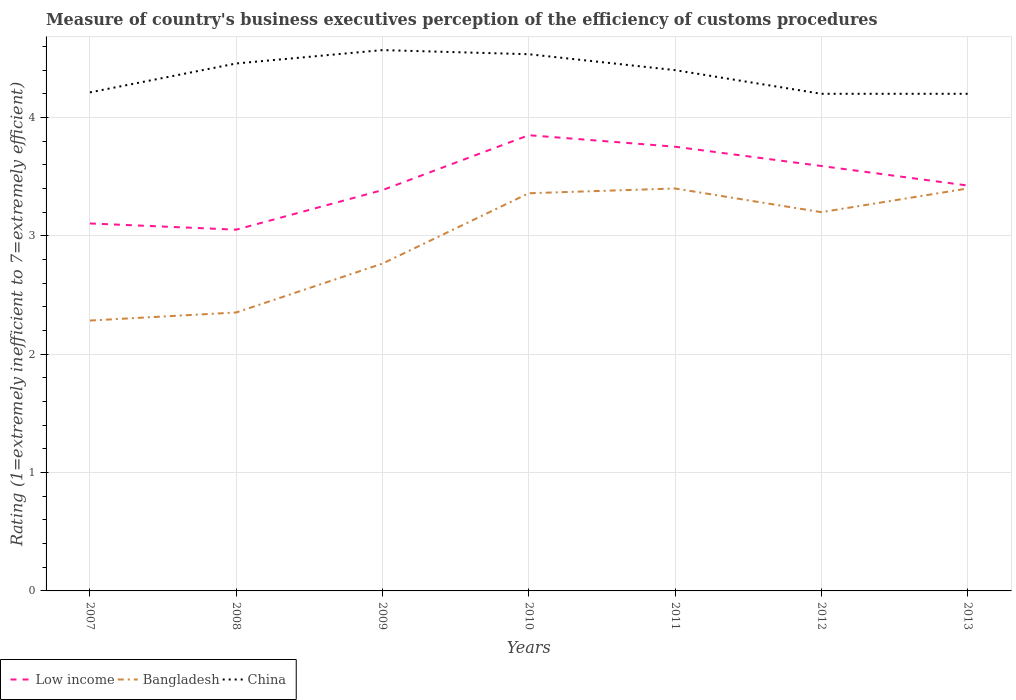How many different coloured lines are there?
Provide a succinct answer. 3. Does the line corresponding to China intersect with the line corresponding to Low income?
Offer a very short reply. No. Is the number of lines equal to the number of legend labels?
Give a very brief answer. Yes. Across all years, what is the maximum rating of the efficiency of customs procedure in Low income?
Offer a very short reply. 3.05. What is the total rating of the efficiency of customs procedure in China in the graph?
Your answer should be very brief. 0.2. What is the difference between the highest and the second highest rating of the efficiency of customs procedure in China?
Ensure brevity in your answer.  0.37. How many lines are there?
Your answer should be very brief. 3. How many years are there in the graph?
Your response must be concise. 7. What is the difference between two consecutive major ticks on the Y-axis?
Keep it short and to the point. 1. Are the values on the major ticks of Y-axis written in scientific E-notation?
Give a very brief answer. No. How many legend labels are there?
Keep it short and to the point. 3. What is the title of the graph?
Provide a succinct answer. Measure of country's business executives perception of the efficiency of customs procedures. Does "Peru" appear as one of the legend labels in the graph?
Make the answer very short. No. What is the label or title of the X-axis?
Provide a short and direct response. Years. What is the label or title of the Y-axis?
Ensure brevity in your answer.  Rating (1=extremely inefficient to 7=extremely efficient). What is the Rating (1=extremely inefficient to 7=extremely efficient) of Low income in 2007?
Provide a succinct answer. 3.1. What is the Rating (1=extremely inefficient to 7=extremely efficient) of Bangladesh in 2007?
Give a very brief answer. 2.28. What is the Rating (1=extremely inefficient to 7=extremely efficient) of China in 2007?
Offer a very short reply. 4.21. What is the Rating (1=extremely inefficient to 7=extremely efficient) in Low income in 2008?
Give a very brief answer. 3.05. What is the Rating (1=extremely inefficient to 7=extremely efficient) in Bangladesh in 2008?
Make the answer very short. 2.35. What is the Rating (1=extremely inefficient to 7=extremely efficient) of China in 2008?
Your response must be concise. 4.46. What is the Rating (1=extremely inefficient to 7=extremely efficient) of Low income in 2009?
Offer a terse response. 3.39. What is the Rating (1=extremely inefficient to 7=extremely efficient) of Bangladesh in 2009?
Provide a short and direct response. 2.77. What is the Rating (1=extremely inefficient to 7=extremely efficient) of China in 2009?
Make the answer very short. 4.57. What is the Rating (1=extremely inefficient to 7=extremely efficient) of Low income in 2010?
Your answer should be very brief. 3.85. What is the Rating (1=extremely inefficient to 7=extremely efficient) of Bangladesh in 2010?
Your answer should be very brief. 3.36. What is the Rating (1=extremely inefficient to 7=extremely efficient) in China in 2010?
Provide a short and direct response. 4.53. What is the Rating (1=extremely inefficient to 7=extremely efficient) of Low income in 2011?
Ensure brevity in your answer.  3.75. What is the Rating (1=extremely inefficient to 7=extremely efficient) in Low income in 2012?
Offer a very short reply. 3.59. What is the Rating (1=extremely inefficient to 7=extremely efficient) in Low income in 2013?
Your response must be concise. 3.42. Across all years, what is the maximum Rating (1=extremely inefficient to 7=extremely efficient) in Low income?
Your answer should be compact. 3.85. Across all years, what is the maximum Rating (1=extremely inefficient to 7=extremely efficient) in China?
Ensure brevity in your answer.  4.57. Across all years, what is the minimum Rating (1=extremely inefficient to 7=extremely efficient) of Low income?
Keep it short and to the point. 3.05. Across all years, what is the minimum Rating (1=extremely inefficient to 7=extremely efficient) in Bangladesh?
Offer a very short reply. 2.28. Across all years, what is the minimum Rating (1=extremely inefficient to 7=extremely efficient) in China?
Ensure brevity in your answer.  4.2. What is the total Rating (1=extremely inefficient to 7=extremely efficient) in Low income in the graph?
Provide a succinct answer. 24.16. What is the total Rating (1=extremely inefficient to 7=extremely efficient) in Bangladesh in the graph?
Ensure brevity in your answer.  20.76. What is the total Rating (1=extremely inefficient to 7=extremely efficient) in China in the graph?
Offer a very short reply. 30.57. What is the difference between the Rating (1=extremely inefficient to 7=extremely efficient) of Low income in 2007 and that in 2008?
Offer a very short reply. 0.05. What is the difference between the Rating (1=extremely inefficient to 7=extremely efficient) of Bangladesh in 2007 and that in 2008?
Provide a succinct answer. -0.07. What is the difference between the Rating (1=extremely inefficient to 7=extremely efficient) in China in 2007 and that in 2008?
Your response must be concise. -0.24. What is the difference between the Rating (1=extremely inefficient to 7=extremely efficient) in Low income in 2007 and that in 2009?
Your response must be concise. -0.28. What is the difference between the Rating (1=extremely inefficient to 7=extremely efficient) in Bangladesh in 2007 and that in 2009?
Provide a succinct answer. -0.48. What is the difference between the Rating (1=extremely inefficient to 7=extremely efficient) of China in 2007 and that in 2009?
Your response must be concise. -0.36. What is the difference between the Rating (1=extremely inefficient to 7=extremely efficient) in Low income in 2007 and that in 2010?
Offer a very short reply. -0.75. What is the difference between the Rating (1=extremely inefficient to 7=extremely efficient) of Bangladesh in 2007 and that in 2010?
Offer a terse response. -1.08. What is the difference between the Rating (1=extremely inefficient to 7=extremely efficient) in China in 2007 and that in 2010?
Provide a succinct answer. -0.32. What is the difference between the Rating (1=extremely inefficient to 7=extremely efficient) of Low income in 2007 and that in 2011?
Keep it short and to the point. -0.65. What is the difference between the Rating (1=extremely inefficient to 7=extremely efficient) in Bangladesh in 2007 and that in 2011?
Provide a succinct answer. -1.12. What is the difference between the Rating (1=extremely inefficient to 7=extremely efficient) in China in 2007 and that in 2011?
Make the answer very short. -0.19. What is the difference between the Rating (1=extremely inefficient to 7=extremely efficient) in Low income in 2007 and that in 2012?
Provide a succinct answer. -0.49. What is the difference between the Rating (1=extremely inefficient to 7=extremely efficient) in Bangladesh in 2007 and that in 2012?
Your answer should be compact. -0.92. What is the difference between the Rating (1=extremely inefficient to 7=extremely efficient) of China in 2007 and that in 2012?
Offer a very short reply. 0.01. What is the difference between the Rating (1=extremely inefficient to 7=extremely efficient) of Low income in 2007 and that in 2013?
Your answer should be very brief. -0.32. What is the difference between the Rating (1=extremely inefficient to 7=extremely efficient) in Bangladesh in 2007 and that in 2013?
Your answer should be compact. -1.12. What is the difference between the Rating (1=extremely inefficient to 7=extremely efficient) of China in 2007 and that in 2013?
Your answer should be compact. 0.01. What is the difference between the Rating (1=extremely inefficient to 7=extremely efficient) in Low income in 2008 and that in 2009?
Give a very brief answer. -0.33. What is the difference between the Rating (1=extremely inefficient to 7=extremely efficient) of Bangladesh in 2008 and that in 2009?
Give a very brief answer. -0.41. What is the difference between the Rating (1=extremely inefficient to 7=extremely efficient) in China in 2008 and that in 2009?
Give a very brief answer. -0.11. What is the difference between the Rating (1=extremely inefficient to 7=extremely efficient) in Low income in 2008 and that in 2010?
Make the answer very short. -0.8. What is the difference between the Rating (1=extremely inefficient to 7=extremely efficient) in Bangladesh in 2008 and that in 2010?
Make the answer very short. -1.01. What is the difference between the Rating (1=extremely inefficient to 7=extremely efficient) in China in 2008 and that in 2010?
Your answer should be compact. -0.08. What is the difference between the Rating (1=extremely inefficient to 7=extremely efficient) in Low income in 2008 and that in 2011?
Keep it short and to the point. -0.7. What is the difference between the Rating (1=extremely inefficient to 7=extremely efficient) of Bangladesh in 2008 and that in 2011?
Make the answer very short. -1.05. What is the difference between the Rating (1=extremely inefficient to 7=extremely efficient) of China in 2008 and that in 2011?
Your answer should be compact. 0.06. What is the difference between the Rating (1=extremely inefficient to 7=extremely efficient) in Low income in 2008 and that in 2012?
Give a very brief answer. -0.54. What is the difference between the Rating (1=extremely inefficient to 7=extremely efficient) in Bangladesh in 2008 and that in 2012?
Your answer should be compact. -0.85. What is the difference between the Rating (1=extremely inefficient to 7=extremely efficient) of China in 2008 and that in 2012?
Your answer should be very brief. 0.26. What is the difference between the Rating (1=extremely inefficient to 7=extremely efficient) in Low income in 2008 and that in 2013?
Your answer should be compact. -0.37. What is the difference between the Rating (1=extremely inefficient to 7=extremely efficient) in Bangladesh in 2008 and that in 2013?
Your response must be concise. -1.05. What is the difference between the Rating (1=extremely inefficient to 7=extremely efficient) in China in 2008 and that in 2013?
Offer a very short reply. 0.26. What is the difference between the Rating (1=extremely inefficient to 7=extremely efficient) in Low income in 2009 and that in 2010?
Provide a short and direct response. -0.46. What is the difference between the Rating (1=extremely inefficient to 7=extremely efficient) of Bangladesh in 2009 and that in 2010?
Your response must be concise. -0.59. What is the difference between the Rating (1=extremely inefficient to 7=extremely efficient) of China in 2009 and that in 2010?
Your response must be concise. 0.03. What is the difference between the Rating (1=extremely inefficient to 7=extremely efficient) of Low income in 2009 and that in 2011?
Provide a succinct answer. -0.37. What is the difference between the Rating (1=extremely inefficient to 7=extremely efficient) in Bangladesh in 2009 and that in 2011?
Provide a succinct answer. -0.63. What is the difference between the Rating (1=extremely inefficient to 7=extremely efficient) in China in 2009 and that in 2011?
Your response must be concise. 0.17. What is the difference between the Rating (1=extremely inefficient to 7=extremely efficient) in Low income in 2009 and that in 2012?
Offer a terse response. -0.2. What is the difference between the Rating (1=extremely inefficient to 7=extremely efficient) in Bangladesh in 2009 and that in 2012?
Offer a terse response. -0.43. What is the difference between the Rating (1=extremely inefficient to 7=extremely efficient) in China in 2009 and that in 2012?
Your response must be concise. 0.37. What is the difference between the Rating (1=extremely inefficient to 7=extremely efficient) in Low income in 2009 and that in 2013?
Keep it short and to the point. -0.04. What is the difference between the Rating (1=extremely inefficient to 7=extremely efficient) in Bangladesh in 2009 and that in 2013?
Give a very brief answer. -0.63. What is the difference between the Rating (1=extremely inefficient to 7=extremely efficient) of China in 2009 and that in 2013?
Give a very brief answer. 0.37. What is the difference between the Rating (1=extremely inefficient to 7=extremely efficient) in Low income in 2010 and that in 2011?
Your response must be concise. 0.1. What is the difference between the Rating (1=extremely inefficient to 7=extremely efficient) in Bangladesh in 2010 and that in 2011?
Give a very brief answer. -0.04. What is the difference between the Rating (1=extremely inefficient to 7=extremely efficient) in China in 2010 and that in 2011?
Your answer should be compact. 0.13. What is the difference between the Rating (1=extremely inefficient to 7=extremely efficient) of Low income in 2010 and that in 2012?
Offer a very short reply. 0.26. What is the difference between the Rating (1=extremely inefficient to 7=extremely efficient) of Bangladesh in 2010 and that in 2012?
Your response must be concise. 0.16. What is the difference between the Rating (1=extremely inefficient to 7=extremely efficient) of China in 2010 and that in 2012?
Your answer should be compact. 0.33. What is the difference between the Rating (1=extremely inefficient to 7=extremely efficient) in Low income in 2010 and that in 2013?
Provide a succinct answer. 0.43. What is the difference between the Rating (1=extremely inefficient to 7=extremely efficient) in Bangladesh in 2010 and that in 2013?
Give a very brief answer. -0.04. What is the difference between the Rating (1=extremely inefficient to 7=extremely efficient) of China in 2010 and that in 2013?
Ensure brevity in your answer.  0.33. What is the difference between the Rating (1=extremely inefficient to 7=extremely efficient) in Low income in 2011 and that in 2012?
Give a very brief answer. 0.16. What is the difference between the Rating (1=extremely inefficient to 7=extremely efficient) in Low income in 2011 and that in 2013?
Ensure brevity in your answer.  0.33. What is the difference between the Rating (1=extremely inefficient to 7=extremely efficient) in Bangladesh in 2011 and that in 2013?
Offer a very short reply. 0. What is the difference between the Rating (1=extremely inefficient to 7=extremely efficient) of China in 2011 and that in 2013?
Offer a terse response. 0.2. What is the difference between the Rating (1=extremely inefficient to 7=extremely efficient) of Low income in 2012 and that in 2013?
Offer a very short reply. 0.17. What is the difference between the Rating (1=extremely inefficient to 7=extremely efficient) in China in 2012 and that in 2013?
Ensure brevity in your answer.  0. What is the difference between the Rating (1=extremely inefficient to 7=extremely efficient) of Low income in 2007 and the Rating (1=extremely inefficient to 7=extremely efficient) of Bangladesh in 2008?
Offer a terse response. 0.75. What is the difference between the Rating (1=extremely inefficient to 7=extremely efficient) in Low income in 2007 and the Rating (1=extremely inefficient to 7=extremely efficient) in China in 2008?
Make the answer very short. -1.35. What is the difference between the Rating (1=extremely inefficient to 7=extremely efficient) of Bangladesh in 2007 and the Rating (1=extremely inefficient to 7=extremely efficient) of China in 2008?
Offer a terse response. -2.17. What is the difference between the Rating (1=extremely inefficient to 7=extremely efficient) of Low income in 2007 and the Rating (1=extremely inefficient to 7=extremely efficient) of Bangladesh in 2009?
Your answer should be very brief. 0.34. What is the difference between the Rating (1=extremely inefficient to 7=extremely efficient) in Low income in 2007 and the Rating (1=extremely inefficient to 7=extremely efficient) in China in 2009?
Give a very brief answer. -1.46. What is the difference between the Rating (1=extremely inefficient to 7=extremely efficient) in Bangladesh in 2007 and the Rating (1=extremely inefficient to 7=extremely efficient) in China in 2009?
Provide a succinct answer. -2.29. What is the difference between the Rating (1=extremely inefficient to 7=extremely efficient) in Low income in 2007 and the Rating (1=extremely inefficient to 7=extremely efficient) in Bangladesh in 2010?
Keep it short and to the point. -0.26. What is the difference between the Rating (1=extremely inefficient to 7=extremely efficient) in Low income in 2007 and the Rating (1=extremely inefficient to 7=extremely efficient) in China in 2010?
Keep it short and to the point. -1.43. What is the difference between the Rating (1=extremely inefficient to 7=extremely efficient) of Bangladesh in 2007 and the Rating (1=extremely inefficient to 7=extremely efficient) of China in 2010?
Ensure brevity in your answer.  -2.25. What is the difference between the Rating (1=extremely inefficient to 7=extremely efficient) in Low income in 2007 and the Rating (1=extremely inefficient to 7=extremely efficient) in Bangladesh in 2011?
Keep it short and to the point. -0.3. What is the difference between the Rating (1=extremely inefficient to 7=extremely efficient) in Low income in 2007 and the Rating (1=extremely inefficient to 7=extremely efficient) in China in 2011?
Ensure brevity in your answer.  -1.3. What is the difference between the Rating (1=extremely inefficient to 7=extremely efficient) in Bangladesh in 2007 and the Rating (1=extremely inefficient to 7=extremely efficient) in China in 2011?
Offer a terse response. -2.12. What is the difference between the Rating (1=extremely inefficient to 7=extremely efficient) of Low income in 2007 and the Rating (1=extremely inefficient to 7=extremely efficient) of Bangladesh in 2012?
Make the answer very short. -0.1. What is the difference between the Rating (1=extremely inefficient to 7=extremely efficient) in Low income in 2007 and the Rating (1=extremely inefficient to 7=extremely efficient) in China in 2012?
Give a very brief answer. -1.1. What is the difference between the Rating (1=extremely inefficient to 7=extremely efficient) in Bangladesh in 2007 and the Rating (1=extremely inefficient to 7=extremely efficient) in China in 2012?
Make the answer very short. -1.92. What is the difference between the Rating (1=extremely inefficient to 7=extremely efficient) in Low income in 2007 and the Rating (1=extremely inefficient to 7=extremely efficient) in Bangladesh in 2013?
Provide a short and direct response. -0.3. What is the difference between the Rating (1=extremely inefficient to 7=extremely efficient) in Low income in 2007 and the Rating (1=extremely inefficient to 7=extremely efficient) in China in 2013?
Provide a short and direct response. -1.1. What is the difference between the Rating (1=extremely inefficient to 7=extremely efficient) of Bangladesh in 2007 and the Rating (1=extremely inefficient to 7=extremely efficient) of China in 2013?
Your answer should be compact. -1.92. What is the difference between the Rating (1=extremely inefficient to 7=extremely efficient) in Low income in 2008 and the Rating (1=extremely inefficient to 7=extremely efficient) in Bangladesh in 2009?
Provide a short and direct response. 0.29. What is the difference between the Rating (1=extremely inefficient to 7=extremely efficient) in Low income in 2008 and the Rating (1=extremely inefficient to 7=extremely efficient) in China in 2009?
Ensure brevity in your answer.  -1.52. What is the difference between the Rating (1=extremely inefficient to 7=extremely efficient) in Bangladesh in 2008 and the Rating (1=extremely inefficient to 7=extremely efficient) in China in 2009?
Your answer should be very brief. -2.22. What is the difference between the Rating (1=extremely inefficient to 7=extremely efficient) of Low income in 2008 and the Rating (1=extremely inefficient to 7=extremely efficient) of Bangladesh in 2010?
Offer a terse response. -0.31. What is the difference between the Rating (1=extremely inefficient to 7=extremely efficient) of Low income in 2008 and the Rating (1=extremely inefficient to 7=extremely efficient) of China in 2010?
Ensure brevity in your answer.  -1.48. What is the difference between the Rating (1=extremely inefficient to 7=extremely efficient) in Bangladesh in 2008 and the Rating (1=extremely inefficient to 7=extremely efficient) in China in 2010?
Offer a terse response. -2.18. What is the difference between the Rating (1=extremely inefficient to 7=extremely efficient) in Low income in 2008 and the Rating (1=extremely inefficient to 7=extremely efficient) in Bangladesh in 2011?
Make the answer very short. -0.35. What is the difference between the Rating (1=extremely inefficient to 7=extremely efficient) in Low income in 2008 and the Rating (1=extremely inefficient to 7=extremely efficient) in China in 2011?
Keep it short and to the point. -1.35. What is the difference between the Rating (1=extremely inefficient to 7=extremely efficient) of Bangladesh in 2008 and the Rating (1=extremely inefficient to 7=extremely efficient) of China in 2011?
Provide a short and direct response. -2.05. What is the difference between the Rating (1=extremely inefficient to 7=extremely efficient) in Low income in 2008 and the Rating (1=extremely inefficient to 7=extremely efficient) in Bangladesh in 2012?
Provide a short and direct response. -0.15. What is the difference between the Rating (1=extremely inefficient to 7=extremely efficient) in Low income in 2008 and the Rating (1=extremely inefficient to 7=extremely efficient) in China in 2012?
Your answer should be very brief. -1.15. What is the difference between the Rating (1=extremely inefficient to 7=extremely efficient) in Bangladesh in 2008 and the Rating (1=extremely inefficient to 7=extremely efficient) in China in 2012?
Offer a very short reply. -1.85. What is the difference between the Rating (1=extremely inefficient to 7=extremely efficient) of Low income in 2008 and the Rating (1=extremely inefficient to 7=extremely efficient) of Bangladesh in 2013?
Offer a very short reply. -0.35. What is the difference between the Rating (1=extremely inefficient to 7=extremely efficient) in Low income in 2008 and the Rating (1=extremely inefficient to 7=extremely efficient) in China in 2013?
Offer a terse response. -1.15. What is the difference between the Rating (1=extremely inefficient to 7=extremely efficient) in Bangladesh in 2008 and the Rating (1=extremely inefficient to 7=extremely efficient) in China in 2013?
Keep it short and to the point. -1.85. What is the difference between the Rating (1=extremely inefficient to 7=extremely efficient) of Low income in 2009 and the Rating (1=extremely inefficient to 7=extremely efficient) of Bangladesh in 2010?
Offer a terse response. 0.03. What is the difference between the Rating (1=extremely inefficient to 7=extremely efficient) of Low income in 2009 and the Rating (1=extremely inefficient to 7=extremely efficient) of China in 2010?
Offer a terse response. -1.15. What is the difference between the Rating (1=extremely inefficient to 7=extremely efficient) of Bangladesh in 2009 and the Rating (1=extremely inefficient to 7=extremely efficient) of China in 2010?
Ensure brevity in your answer.  -1.77. What is the difference between the Rating (1=extremely inefficient to 7=extremely efficient) in Low income in 2009 and the Rating (1=extremely inefficient to 7=extremely efficient) in Bangladesh in 2011?
Make the answer very short. -0.01. What is the difference between the Rating (1=extremely inefficient to 7=extremely efficient) of Low income in 2009 and the Rating (1=extremely inefficient to 7=extremely efficient) of China in 2011?
Your answer should be very brief. -1.01. What is the difference between the Rating (1=extremely inefficient to 7=extremely efficient) in Bangladesh in 2009 and the Rating (1=extremely inefficient to 7=extremely efficient) in China in 2011?
Offer a very short reply. -1.63. What is the difference between the Rating (1=extremely inefficient to 7=extremely efficient) of Low income in 2009 and the Rating (1=extremely inefficient to 7=extremely efficient) of Bangladesh in 2012?
Keep it short and to the point. 0.19. What is the difference between the Rating (1=extremely inefficient to 7=extremely efficient) of Low income in 2009 and the Rating (1=extremely inefficient to 7=extremely efficient) of China in 2012?
Your answer should be very brief. -0.81. What is the difference between the Rating (1=extremely inefficient to 7=extremely efficient) in Bangladesh in 2009 and the Rating (1=extremely inefficient to 7=extremely efficient) in China in 2012?
Give a very brief answer. -1.43. What is the difference between the Rating (1=extremely inefficient to 7=extremely efficient) of Low income in 2009 and the Rating (1=extremely inefficient to 7=extremely efficient) of Bangladesh in 2013?
Keep it short and to the point. -0.01. What is the difference between the Rating (1=extremely inefficient to 7=extremely efficient) of Low income in 2009 and the Rating (1=extremely inefficient to 7=extremely efficient) of China in 2013?
Give a very brief answer. -0.81. What is the difference between the Rating (1=extremely inefficient to 7=extremely efficient) in Bangladesh in 2009 and the Rating (1=extremely inefficient to 7=extremely efficient) in China in 2013?
Offer a very short reply. -1.43. What is the difference between the Rating (1=extremely inefficient to 7=extremely efficient) in Low income in 2010 and the Rating (1=extremely inefficient to 7=extremely efficient) in Bangladesh in 2011?
Your response must be concise. 0.45. What is the difference between the Rating (1=extremely inefficient to 7=extremely efficient) in Low income in 2010 and the Rating (1=extremely inefficient to 7=extremely efficient) in China in 2011?
Your answer should be compact. -0.55. What is the difference between the Rating (1=extremely inefficient to 7=extremely efficient) in Bangladesh in 2010 and the Rating (1=extremely inefficient to 7=extremely efficient) in China in 2011?
Your answer should be compact. -1.04. What is the difference between the Rating (1=extremely inefficient to 7=extremely efficient) in Low income in 2010 and the Rating (1=extremely inefficient to 7=extremely efficient) in Bangladesh in 2012?
Offer a very short reply. 0.65. What is the difference between the Rating (1=extremely inefficient to 7=extremely efficient) of Low income in 2010 and the Rating (1=extremely inefficient to 7=extremely efficient) of China in 2012?
Give a very brief answer. -0.35. What is the difference between the Rating (1=extremely inefficient to 7=extremely efficient) in Bangladesh in 2010 and the Rating (1=extremely inefficient to 7=extremely efficient) in China in 2012?
Give a very brief answer. -0.84. What is the difference between the Rating (1=extremely inefficient to 7=extremely efficient) of Low income in 2010 and the Rating (1=extremely inefficient to 7=extremely efficient) of Bangladesh in 2013?
Ensure brevity in your answer.  0.45. What is the difference between the Rating (1=extremely inefficient to 7=extremely efficient) in Low income in 2010 and the Rating (1=extremely inefficient to 7=extremely efficient) in China in 2013?
Ensure brevity in your answer.  -0.35. What is the difference between the Rating (1=extremely inefficient to 7=extremely efficient) in Bangladesh in 2010 and the Rating (1=extremely inefficient to 7=extremely efficient) in China in 2013?
Offer a very short reply. -0.84. What is the difference between the Rating (1=extremely inefficient to 7=extremely efficient) in Low income in 2011 and the Rating (1=extremely inefficient to 7=extremely efficient) in Bangladesh in 2012?
Your answer should be very brief. 0.55. What is the difference between the Rating (1=extremely inefficient to 7=extremely efficient) in Low income in 2011 and the Rating (1=extremely inefficient to 7=extremely efficient) in China in 2012?
Keep it short and to the point. -0.45. What is the difference between the Rating (1=extremely inefficient to 7=extremely efficient) in Low income in 2011 and the Rating (1=extremely inefficient to 7=extremely efficient) in Bangladesh in 2013?
Provide a short and direct response. 0.35. What is the difference between the Rating (1=extremely inefficient to 7=extremely efficient) of Low income in 2011 and the Rating (1=extremely inefficient to 7=extremely efficient) of China in 2013?
Your answer should be very brief. -0.45. What is the difference between the Rating (1=extremely inefficient to 7=extremely efficient) of Low income in 2012 and the Rating (1=extremely inefficient to 7=extremely efficient) of Bangladesh in 2013?
Give a very brief answer. 0.19. What is the difference between the Rating (1=extremely inefficient to 7=extremely efficient) of Low income in 2012 and the Rating (1=extremely inefficient to 7=extremely efficient) of China in 2013?
Make the answer very short. -0.61. What is the average Rating (1=extremely inefficient to 7=extremely efficient) of Low income per year?
Offer a very short reply. 3.45. What is the average Rating (1=extremely inefficient to 7=extremely efficient) in Bangladesh per year?
Provide a succinct answer. 2.97. What is the average Rating (1=extremely inefficient to 7=extremely efficient) of China per year?
Offer a very short reply. 4.37. In the year 2007, what is the difference between the Rating (1=extremely inefficient to 7=extremely efficient) in Low income and Rating (1=extremely inefficient to 7=extremely efficient) in Bangladesh?
Ensure brevity in your answer.  0.82. In the year 2007, what is the difference between the Rating (1=extremely inefficient to 7=extremely efficient) of Low income and Rating (1=extremely inefficient to 7=extremely efficient) of China?
Provide a short and direct response. -1.11. In the year 2007, what is the difference between the Rating (1=extremely inefficient to 7=extremely efficient) in Bangladesh and Rating (1=extremely inefficient to 7=extremely efficient) in China?
Your answer should be compact. -1.93. In the year 2008, what is the difference between the Rating (1=extremely inefficient to 7=extremely efficient) in Low income and Rating (1=extremely inefficient to 7=extremely efficient) in Bangladesh?
Your response must be concise. 0.7. In the year 2008, what is the difference between the Rating (1=extremely inefficient to 7=extremely efficient) of Low income and Rating (1=extremely inefficient to 7=extremely efficient) of China?
Provide a short and direct response. -1.4. In the year 2008, what is the difference between the Rating (1=extremely inefficient to 7=extremely efficient) in Bangladesh and Rating (1=extremely inefficient to 7=extremely efficient) in China?
Provide a succinct answer. -2.1. In the year 2009, what is the difference between the Rating (1=extremely inefficient to 7=extremely efficient) of Low income and Rating (1=extremely inefficient to 7=extremely efficient) of Bangladesh?
Keep it short and to the point. 0.62. In the year 2009, what is the difference between the Rating (1=extremely inefficient to 7=extremely efficient) of Low income and Rating (1=extremely inefficient to 7=extremely efficient) of China?
Offer a terse response. -1.18. In the year 2009, what is the difference between the Rating (1=extremely inefficient to 7=extremely efficient) in Bangladesh and Rating (1=extremely inefficient to 7=extremely efficient) in China?
Offer a very short reply. -1.8. In the year 2010, what is the difference between the Rating (1=extremely inefficient to 7=extremely efficient) of Low income and Rating (1=extremely inefficient to 7=extremely efficient) of Bangladesh?
Ensure brevity in your answer.  0.49. In the year 2010, what is the difference between the Rating (1=extremely inefficient to 7=extremely efficient) of Low income and Rating (1=extremely inefficient to 7=extremely efficient) of China?
Your answer should be very brief. -0.68. In the year 2010, what is the difference between the Rating (1=extremely inefficient to 7=extremely efficient) of Bangladesh and Rating (1=extremely inefficient to 7=extremely efficient) of China?
Provide a succinct answer. -1.17. In the year 2011, what is the difference between the Rating (1=extremely inefficient to 7=extremely efficient) in Low income and Rating (1=extremely inefficient to 7=extremely efficient) in Bangladesh?
Offer a terse response. 0.35. In the year 2011, what is the difference between the Rating (1=extremely inefficient to 7=extremely efficient) in Low income and Rating (1=extremely inefficient to 7=extremely efficient) in China?
Make the answer very short. -0.65. In the year 2011, what is the difference between the Rating (1=extremely inefficient to 7=extremely efficient) of Bangladesh and Rating (1=extremely inefficient to 7=extremely efficient) of China?
Provide a succinct answer. -1. In the year 2012, what is the difference between the Rating (1=extremely inefficient to 7=extremely efficient) of Low income and Rating (1=extremely inefficient to 7=extremely efficient) of Bangladesh?
Your response must be concise. 0.39. In the year 2012, what is the difference between the Rating (1=extremely inefficient to 7=extremely efficient) of Low income and Rating (1=extremely inefficient to 7=extremely efficient) of China?
Offer a very short reply. -0.61. In the year 2012, what is the difference between the Rating (1=extremely inefficient to 7=extremely efficient) of Bangladesh and Rating (1=extremely inefficient to 7=extremely efficient) of China?
Offer a very short reply. -1. In the year 2013, what is the difference between the Rating (1=extremely inefficient to 7=extremely efficient) in Low income and Rating (1=extremely inefficient to 7=extremely efficient) in Bangladesh?
Provide a succinct answer. 0.03. In the year 2013, what is the difference between the Rating (1=extremely inefficient to 7=extremely efficient) in Low income and Rating (1=extremely inefficient to 7=extremely efficient) in China?
Your answer should be very brief. -0.78. In the year 2013, what is the difference between the Rating (1=extremely inefficient to 7=extremely efficient) in Bangladesh and Rating (1=extremely inefficient to 7=extremely efficient) in China?
Your answer should be compact. -0.8. What is the ratio of the Rating (1=extremely inefficient to 7=extremely efficient) in Low income in 2007 to that in 2008?
Give a very brief answer. 1.02. What is the ratio of the Rating (1=extremely inefficient to 7=extremely efficient) of Bangladesh in 2007 to that in 2008?
Keep it short and to the point. 0.97. What is the ratio of the Rating (1=extremely inefficient to 7=extremely efficient) of China in 2007 to that in 2008?
Give a very brief answer. 0.95. What is the ratio of the Rating (1=extremely inefficient to 7=extremely efficient) of Low income in 2007 to that in 2009?
Give a very brief answer. 0.92. What is the ratio of the Rating (1=extremely inefficient to 7=extremely efficient) of Bangladesh in 2007 to that in 2009?
Your response must be concise. 0.83. What is the ratio of the Rating (1=extremely inefficient to 7=extremely efficient) in China in 2007 to that in 2009?
Give a very brief answer. 0.92. What is the ratio of the Rating (1=extremely inefficient to 7=extremely efficient) in Low income in 2007 to that in 2010?
Your answer should be compact. 0.81. What is the ratio of the Rating (1=extremely inefficient to 7=extremely efficient) in Bangladesh in 2007 to that in 2010?
Your answer should be very brief. 0.68. What is the ratio of the Rating (1=extremely inefficient to 7=extremely efficient) in China in 2007 to that in 2010?
Your answer should be compact. 0.93. What is the ratio of the Rating (1=extremely inefficient to 7=extremely efficient) of Low income in 2007 to that in 2011?
Your answer should be compact. 0.83. What is the ratio of the Rating (1=extremely inefficient to 7=extremely efficient) in Bangladesh in 2007 to that in 2011?
Your answer should be compact. 0.67. What is the ratio of the Rating (1=extremely inefficient to 7=extremely efficient) of China in 2007 to that in 2011?
Give a very brief answer. 0.96. What is the ratio of the Rating (1=extremely inefficient to 7=extremely efficient) of Low income in 2007 to that in 2012?
Provide a succinct answer. 0.86. What is the ratio of the Rating (1=extremely inefficient to 7=extremely efficient) of Bangladesh in 2007 to that in 2012?
Provide a short and direct response. 0.71. What is the ratio of the Rating (1=extremely inefficient to 7=extremely efficient) of China in 2007 to that in 2012?
Your answer should be compact. 1. What is the ratio of the Rating (1=extremely inefficient to 7=extremely efficient) in Low income in 2007 to that in 2013?
Give a very brief answer. 0.91. What is the ratio of the Rating (1=extremely inefficient to 7=extremely efficient) of Bangladesh in 2007 to that in 2013?
Your answer should be very brief. 0.67. What is the ratio of the Rating (1=extremely inefficient to 7=extremely efficient) in Low income in 2008 to that in 2009?
Provide a succinct answer. 0.9. What is the ratio of the Rating (1=extremely inefficient to 7=extremely efficient) of Bangladesh in 2008 to that in 2009?
Provide a short and direct response. 0.85. What is the ratio of the Rating (1=extremely inefficient to 7=extremely efficient) in China in 2008 to that in 2009?
Make the answer very short. 0.98. What is the ratio of the Rating (1=extremely inefficient to 7=extremely efficient) in Low income in 2008 to that in 2010?
Your response must be concise. 0.79. What is the ratio of the Rating (1=extremely inefficient to 7=extremely efficient) in Bangladesh in 2008 to that in 2010?
Give a very brief answer. 0.7. What is the ratio of the Rating (1=extremely inefficient to 7=extremely efficient) of China in 2008 to that in 2010?
Make the answer very short. 0.98. What is the ratio of the Rating (1=extremely inefficient to 7=extremely efficient) in Low income in 2008 to that in 2011?
Your answer should be very brief. 0.81. What is the ratio of the Rating (1=extremely inefficient to 7=extremely efficient) of Bangladesh in 2008 to that in 2011?
Your response must be concise. 0.69. What is the ratio of the Rating (1=extremely inefficient to 7=extremely efficient) of China in 2008 to that in 2011?
Offer a terse response. 1.01. What is the ratio of the Rating (1=extremely inefficient to 7=extremely efficient) of Low income in 2008 to that in 2012?
Ensure brevity in your answer.  0.85. What is the ratio of the Rating (1=extremely inefficient to 7=extremely efficient) of Bangladesh in 2008 to that in 2012?
Your response must be concise. 0.74. What is the ratio of the Rating (1=extremely inefficient to 7=extremely efficient) in China in 2008 to that in 2012?
Provide a short and direct response. 1.06. What is the ratio of the Rating (1=extremely inefficient to 7=extremely efficient) in Low income in 2008 to that in 2013?
Provide a short and direct response. 0.89. What is the ratio of the Rating (1=extremely inefficient to 7=extremely efficient) in Bangladesh in 2008 to that in 2013?
Your answer should be very brief. 0.69. What is the ratio of the Rating (1=extremely inefficient to 7=extremely efficient) of China in 2008 to that in 2013?
Offer a very short reply. 1.06. What is the ratio of the Rating (1=extremely inefficient to 7=extremely efficient) in Low income in 2009 to that in 2010?
Your answer should be very brief. 0.88. What is the ratio of the Rating (1=extremely inefficient to 7=extremely efficient) in Bangladesh in 2009 to that in 2010?
Your answer should be very brief. 0.82. What is the ratio of the Rating (1=extremely inefficient to 7=extremely efficient) in China in 2009 to that in 2010?
Your response must be concise. 1.01. What is the ratio of the Rating (1=extremely inefficient to 7=extremely efficient) in Low income in 2009 to that in 2011?
Provide a short and direct response. 0.9. What is the ratio of the Rating (1=extremely inefficient to 7=extremely efficient) of Bangladesh in 2009 to that in 2011?
Provide a succinct answer. 0.81. What is the ratio of the Rating (1=extremely inefficient to 7=extremely efficient) in China in 2009 to that in 2011?
Your answer should be very brief. 1.04. What is the ratio of the Rating (1=extremely inefficient to 7=extremely efficient) in Low income in 2009 to that in 2012?
Provide a short and direct response. 0.94. What is the ratio of the Rating (1=extremely inefficient to 7=extremely efficient) in Bangladesh in 2009 to that in 2012?
Give a very brief answer. 0.86. What is the ratio of the Rating (1=extremely inefficient to 7=extremely efficient) of China in 2009 to that in 2012?
Your answer should be very brief. 1.09. What is the ratio of the Rating (1=extremely inefficient to 7=extremely efficient) of Low income in 2009 to that in 2013?
Your answer should be very brief. 0.99. What is the ratio of the Rating (1=extremely inefficient to 7=extremely efficient) in Bangladesh in 2009 to that in 2013?
Make the answer very short. 0.81. What is the ratio of the Rating (1=extremely inefficient to 7=extremely efficient) of China in 2009 to that in 2013?
Give a very brief answer. 1.09. What is the ratio of the Rating (1=extremely inefficient to 7=extremely efficient) of Low income in 2010 to that in 2011?
Your response must be concise. 1.03. What is the ratio of the Rating (1=extremely inefficient to 7=extremely efficient) in China in 2010 to that in 2011?
Provide a succinct answer. 1.03. What is the ratio of the Rating (1=extremely inefficient to 7=extremely efficient) in Low income in 2010 to that in 2012?
Your answer should be compact. 1.07. What is the ratio of the Rating (1=extremely inefficient to 7=extremely efficient) in Bangladesh in 2010 to that in 2012?
Provide a succinct answer. 1.05. What is the ratio of the Rating (1=extremely inefficient to 7=extremely efficient) of China in 2010 to that in 2012?
Ensure brevity in your answer.  1.08. What is the ratio of the Rating (1=extremely inefficient to 7=extremely efficient) of Low income in 2010 to that in 2013?
Your answer should be very brief. 1.12. What is the ratio of the Rating (1=extremely inefficient to 7=extremely efficient) in China in 2010 to that in 2013?
Make the answer very short. 1.08. What is the ratio of the Rating (1=extremely inefficient to 7=extremely efficient) in Low income in 2011 to that in 2012?
Ensure brevity in your answer.  1.05. What is the ratio of the Rating (1=extremely inefficient to 7=extremely efficient) in Bangladesh in 2011 to that in 2012?
Keep it short and to the point. 1.06. What is the ratio of the Rating (1=extremely inefficient to 7=extremely efficient) in China in 2011 to that in 2012?
Ensure brevity in your answer.  1.05. What is the ratio of the Rating (1=extremely inefficient to 7=extremely efficient) of Low income in 2011 to that in 2013?
Provide a short and direct response. 1.1. What is the ratio of the Rating (1=extremely inefficient to 7=extremely efficient) of China in 2011 to that in 2013?
Keep it short and to the point. 1.05. What is the ratio of the Rating (1=extremely inefficient to 7=extremely efficient) of Low income in 2012 to that in 2013?
Keep it short and to the point. 1.05. What is the ratio of the Rating (1=extremely inefficient to 7=extremely efficient) of Bangladesh in 2012 to that in 2013?
Ensure brevity in your answer.  0.94. What is the difference between the highest and the second highest Rating (1=extremely inefficient to 7=extremely efficient) of Low income?
Ensure brevity in your answer.  0.1. What is the difference between the highest and the second highest Rating (1=extremely inefficient to 7=extremely efficient) in Bangladesh?
Offer a terse response. 0. What is the difference between the highest and the second highest Rating (1=extremely inefficient to 7=extremely efficient) in China?
Offer a terse response. 0.03. What is the difference between the highest and the lowest Rating (1=extremely inefficient to 7=extremely efficient) of Low income?
Your response must be concise. 0.8. What is the difference between the highest and the lowest Rating (1=extremely inefficient to 7=extremely efficient) in Bangladesh?
Give a very brief answer. 1.12. What is the difference between the highest and the lowest Rating (1=extremely inefficient to 7=extremely efficient) in China?
Make the answer very short. 0.37. 